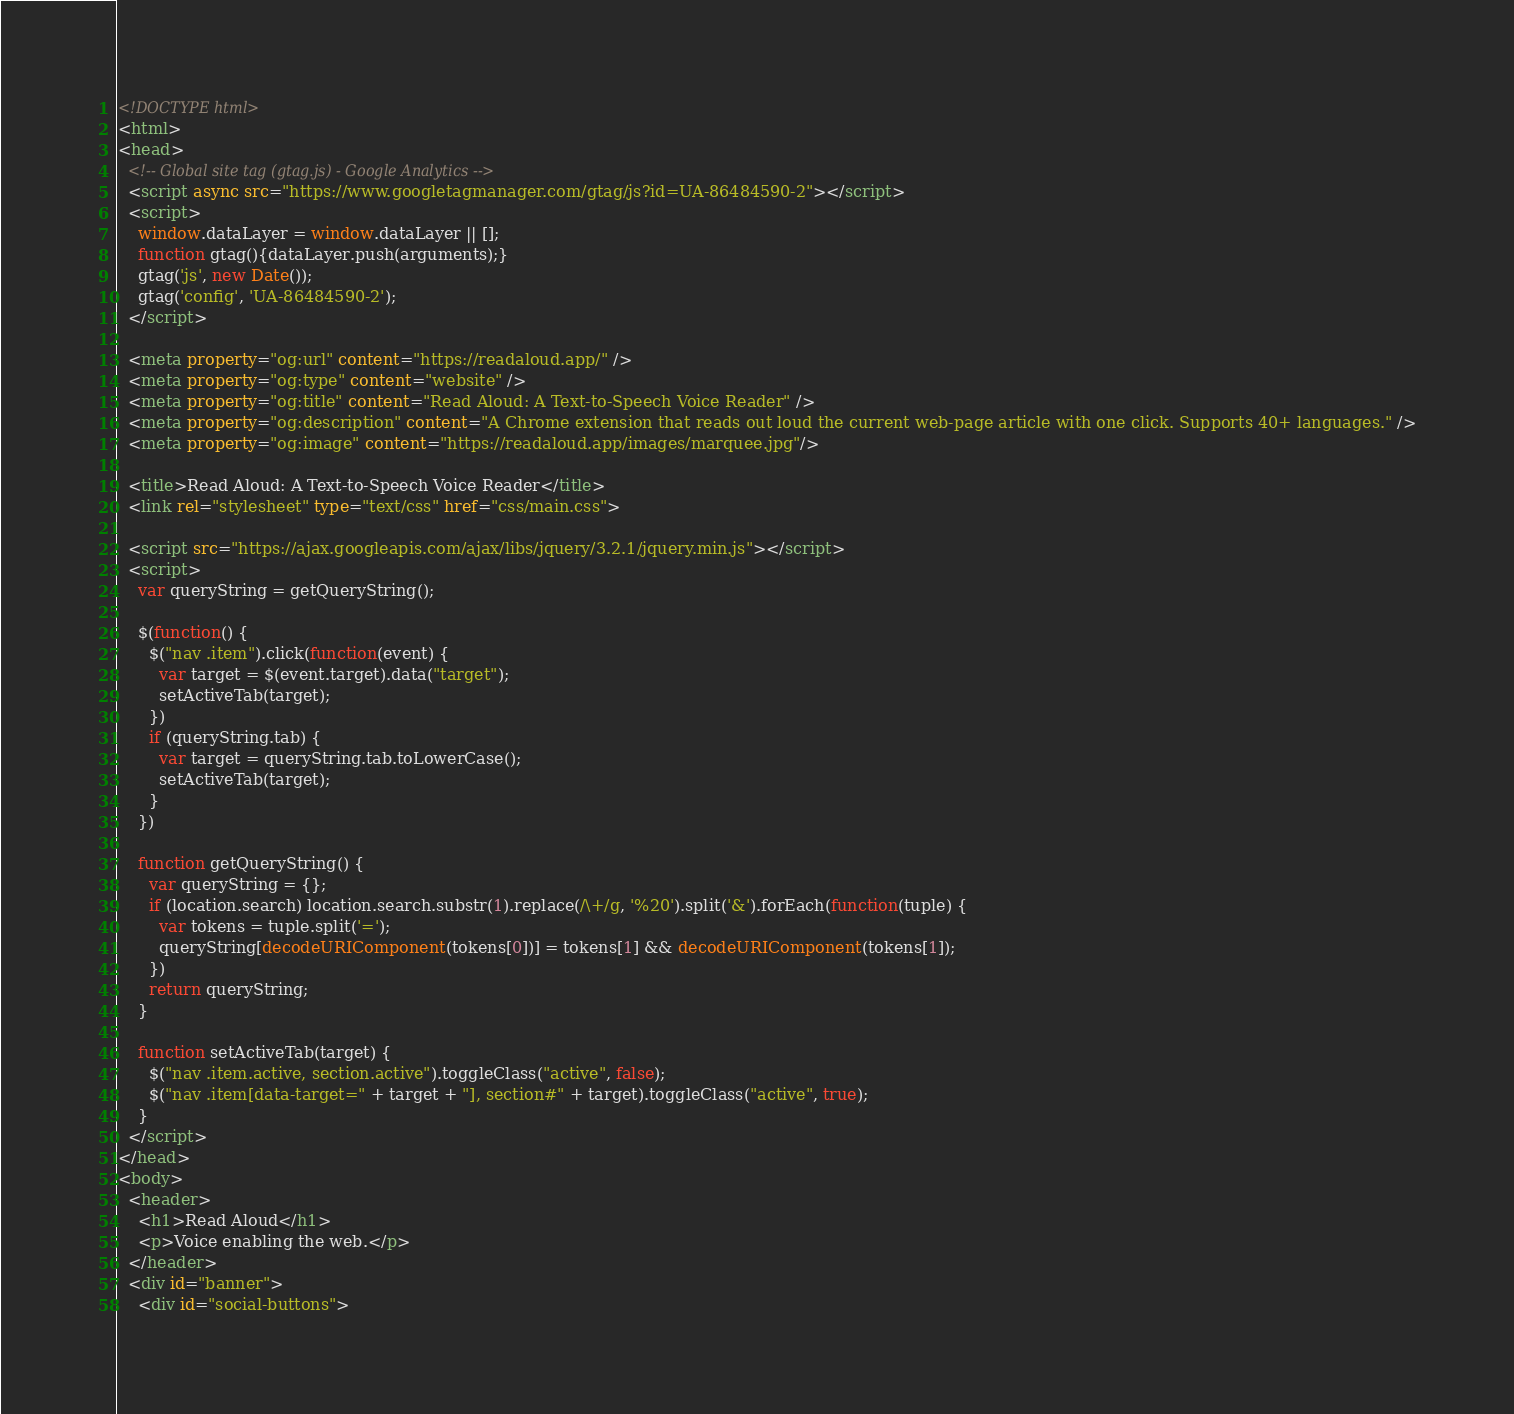<code> <loc_0><loc_0><loc_500><loc_500><_HTML_><!DOCTYPE html>
<html>
<head>
  <!-- Global site tag (gtag.js) - Google Analytics -->
  <script async src="https://www.googletagmanager.com/gtag/js?id=UA-86484590-2"></script>
  <script>
    window.dataLayer = window.dataLayer || [];
    function gtag(){dataLayer.push(arguments);}
    gtag('js', new Date());
    gtag('config', 'UA-86484590-2');
  </script>

  <meta property="og:url" content="https://readaloud.app/" />
  <meta property="og:type" content="website" />
  <meta property="og:title" content="Read Aloud: A Text-to-Speech Voice Reader" />
  <meta property="og:description" content="A Chrome extension that reads out loud the current web-page article with one click. Supports 40+ languages." />
  <meta property="og:image" content="https://readaloud.app/images/marquee.jpg"/>

  <title>Read Aloud: A Text-to-Speech Voice Reader</title>
  <link rel="stylesheet" type="text/css" href="css/main.css">

  <script src="https://ajax.googleapis.com/ajax/libs/jquery/3.2.1/jquery.min.js"></script>
  <script>
    var queryString = getQueryString();

    $(function() {
      $("nav .item").click(function(event) {
        var target = $(event.target).data("target");
        setActiveTab(target);
      })
      if (queryString.tab) {
        var target = queryString.tab.toLowerCase();
        setActiveTab(target);
      }
    })

    function getQueryString() {
      var queryString = {};
      if (location.search) location.search.substr(1).replace(/\+/g, '%20').split('&').forEach(function(tuple) {
        var tokens = tuple.split('=');
        queryString[decodeURIComponent(tokens[0])] = tokens[1] && decodeURIComponent(tokens[1]);
      })
      return queryString;
    }

    function setActiveTab(target) {
      $("nav .item.active, section.active").toggleClass("active", false);
      $("nav .item[data-target=" + target + "], section#" + target).toggleClass("active", true);
    }
  </script>
</head>
<body>
  <header>
    <h1>Read Aloud</h1>
    <p>Voice enabling the web.</p>
  </header>
  <div id="banner">
    <div id="social-buttons"></code> 